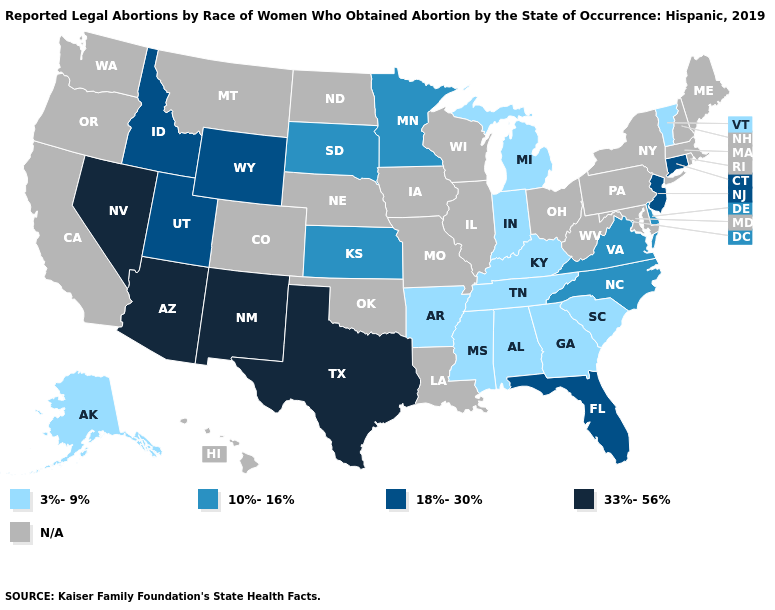Name the states that have a value in the range N/A?
Answer briefly. California, Colorado, Hawaii, Illinois, Iowa, Louisiana, Maine, Maryland, Massachusetts, Missouri, Montana, Nebraska, New Hampshire, New York, North Dakota, Ohio, Oklahoma, Oregon, Pennsylvania, Rhode Island, Washington, West Virginia, Wisconsin. Name the states that have a value in the range 10%-16%?
Be succinct. Delaware, Kansas, Minnesota, North Carolina, South Dakota, Virginia. Name the states that have a value in the range 18%-30%?
Quick response, please. Connecticut, Florida, Idaho, New Jersey, Utah, Wyoming. Which states have the lowest value in the West?
Write a very short answer. Alaska. What is the highest value in the USA?
Write a very short answer. 33%-56%. Among the states that border Idaho , which have the lowest value?
Answer briefly. Utah, Wyoming. What is the value of North Carolina?
Quick response, please. 10%-16%. What is the value of New Hampshire?
Concise answer only. N/A. Name the states that have a value in the range 18%-30%?
Answer briefly. Connecticut, Florida, Idaho, New Jersey, Utah, Wyoming. What is the highest value in the Northeast ?
Keep it brief. 18%-30%. Does Connecticut have the lowest value in the Northeast?
Short answer required. No. Name the states that have a value in the range 33%-56%?
Answer briefly. Arizona, Nevada, New Mexico, Texas. What is the highest value in the USA?
Short answer required. 33%-56%. 